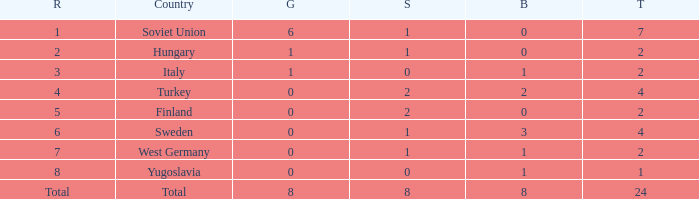What is the average Bronze, when Total is 7, and when Silver is greater than 1? None. 